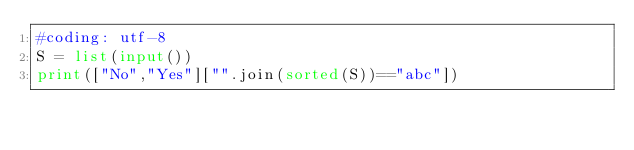<code> <loc_0><loc_0><loc_500><loc_500><_Python_>#coding: utf-8
S = list(input())
print(["No","Yes"]["".join(sorted(S))=="abc"])</code> 